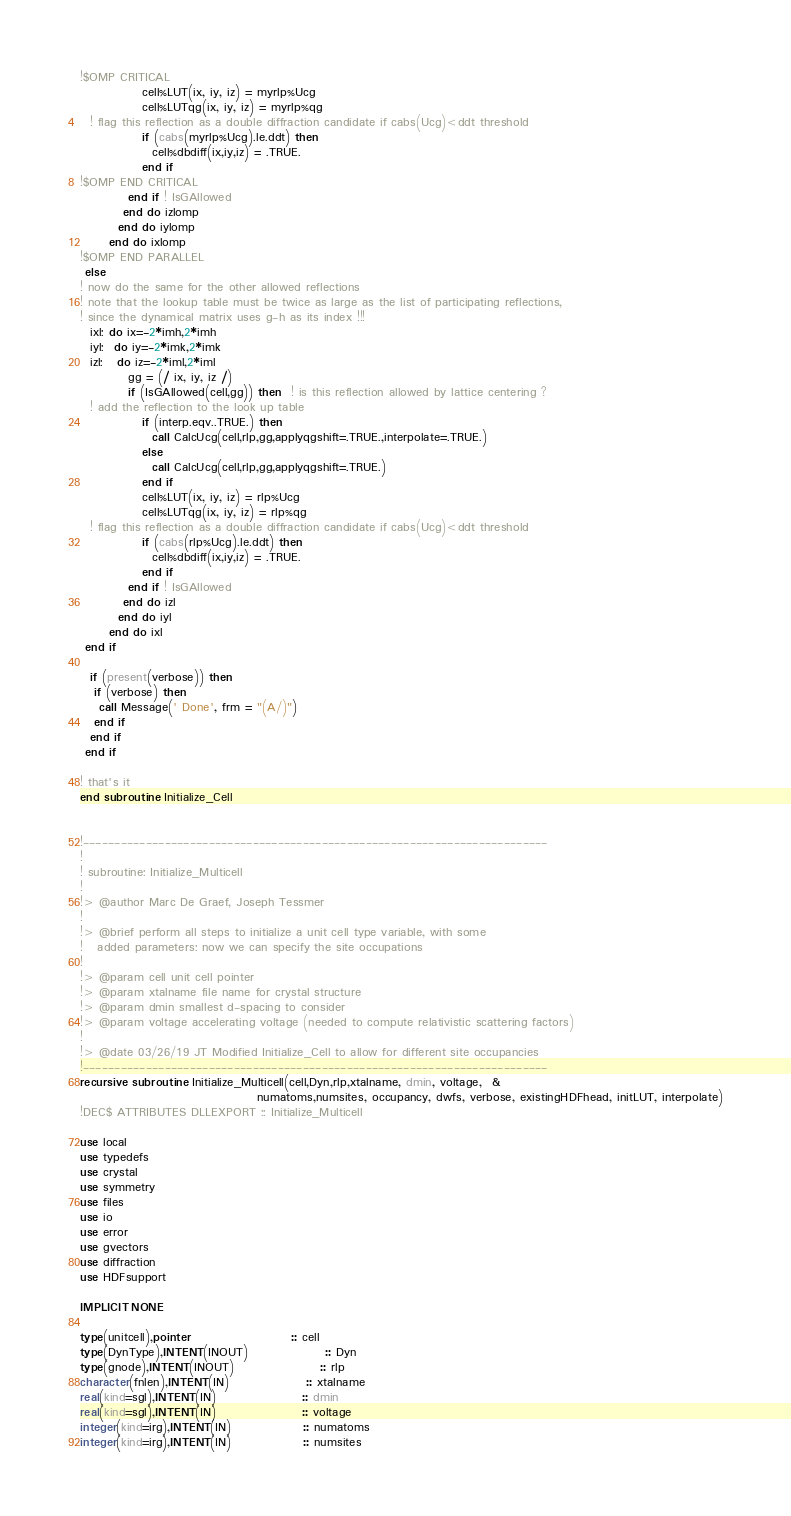Convert code to text. <code><loc_0><loc_0><loc_500><loc_500><_FORTRAN_>!$OMP CRITICAL
             cell%LUT(ix, iy, iz) = myrlp%Ucg
             cell%LUTqg(ix, iy, iz) = myrlp%qg
  ! flag this reflection as a double diffraction candidate if cabs(Ucg)<ddt threshold
             if (cabs(myrlp%Ucg).le.ddt) then 
               cell%dbdiff(ix,iy,iz) = .TRUE.
             end if
!$OMP END CRITICAL
          end if ! IsGAllowed
         end do izlomp
        end do iylomp
      end do ixlomp
!$OMP END PARALLEL 
 else
! now do the same for the other allowed reflections
! note that the lookup table must be twice as large as the list of participating reflections,
! since the dynamical matrix uses g-h as its index !!!  
  ixl: do ix=-2*imh,2*imh
  iyl:  do iy=-2*imk,2*imk
  izl:   do iz=-2*iml,2*iml
          gg = (/ ix, iy, iz /)
          if (IsGAllowed(cell,gg)) then  ! is this reflection allowed by lattice centering ?
  ! add the reflection to the look up table
             if (interp.eqv..TRUE.) then          
               call CalcUcg(cell,rlp,gg,applyqgshift=.TRUE.,interpolate=.TRUE.)
             else
               call CalcUcg(cell,rlp,gg,applyqgshift=.TRUE.)
             end if
             cell%LUT(ix, iy, iz) = rlp%Ucg
             cell%LUTqg(ix, iy, iz) = rlp%qg
  ! flag this reflection as a double diffraction candidate if cabs(Ucg)<ddt threshold
             if (cabs(rlp%Ucg).le.ddt) then 
               cell%dbdiff(ix,iy,iz) = .TRUE.
             end if
          end if ! IsGAllowed
         end do izl
        end do iyl
      end do ixl
 end if

  if (present(verbose)) then
   if (verbose) then
    call Message(' Done', frm = "(A/)")
   end if
  end if
 end if  

! that's it
end subroutine Initialize_Cell


!--------------------------------------------------------------------------
!
! subroutine: Initialize_Multicell
!
!> @author Marc De Graef, Joseph Tessmer
!
!> @brief perform all steps to initialize a unit cell type variable, with some 
!   added parameters: now we can specify the site occupations
!
!> @param cell unit cell pointer
!> @param xtalname file name for crystal structure
!> @param dmin smallest d-spacing to consider
!> @param voltage accelerating voltage (needed to compute relativistic scattering factors)
!
!> @date 03/26/19 JT Modified Initialize_Cell to allow for different site occupancies
!--------------------------------------------------------------------------
recursive subroutine Initialize_Multicell(cell,Dyn,rlp,xtalname, dmin, voltage,  &
                                     numatoms,numsites, occupancy, dwfs, verbose, existingHDFhead, initLUT, interpolate)
!DEC$ ATTRIBUTES DLLEXPORT :: Initialize_Multicell

use local
use typedefs
use crystal
use symmetry
use files
use io
use error
use gvectors
use diffraction
use HDFsupport

IMPLICIT NONE

type(unitcell),pointer                     :: cell
type(DynType),INTENT(INOUT)                :: Dyn
type(gnode),INTENT(INOUT)                  :: rlp
character(fnlen),INTENT(IN)                :: xtalname
real(kind=sgl),INTENT(IN)                  :: dmin
real(kind=sgl),INTENT(IN)                  :: voltage
integer(kind=irg),INTENT(IN)               :: numatoms
integer(kind=irg),INTENT(IN)               :: numsites</code> 